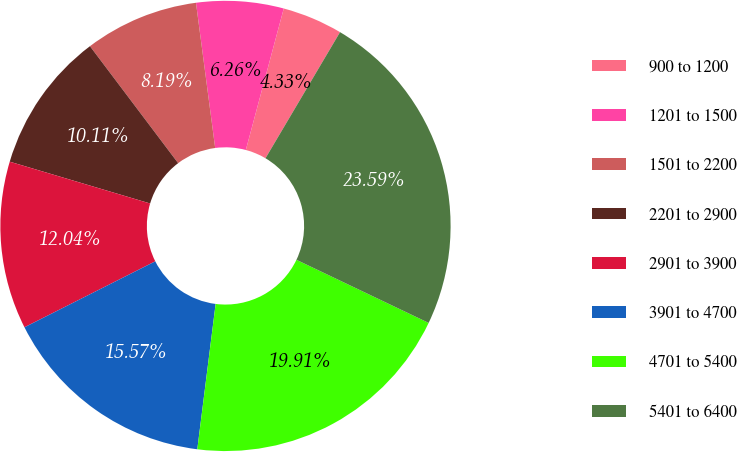Convert chart. <chart><loc_0><loc_0><loc_500><loc_500><pie_chart><fcel>900 to 1200<fcel>1201 to 1500<fcel>1501 to 2200<fcel>2201 to 2900<fcel>2901 to 3900<fcel>3901 to 4700<fcel>4701 to 5400<fcel>5401 to 6400<nl><fcel>4.33%<fcel>6.26%<fcel>8.19%<fcel>10.11%<fcel>12.04%<fcel>15.57%<fcel>19.91%<fcel>23.59%<nl></chart> 